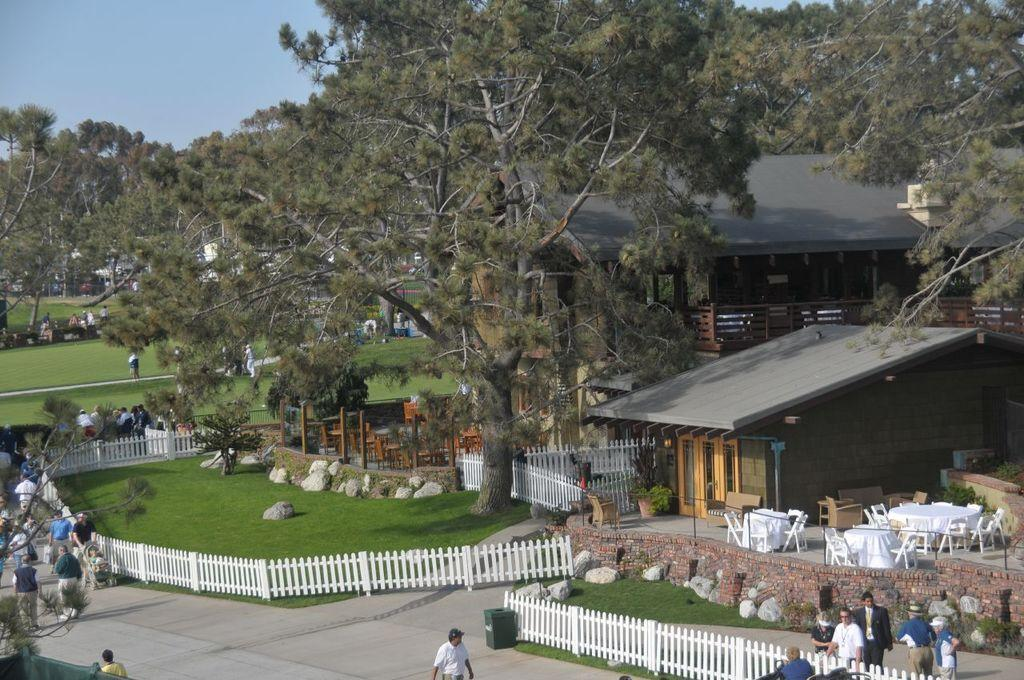What type of structures can be seen in the image? There are houses in the image. What type of vegetation is present in the image? There are trees and grass in the image. Are there any living beings in the image? Yes, there are people in the image. What is the condition of the nail in the image? There is no nail present in the image. What type of industry can be seen in the image? There is no industry present in the image; it features houses, trees, grass, and people. 